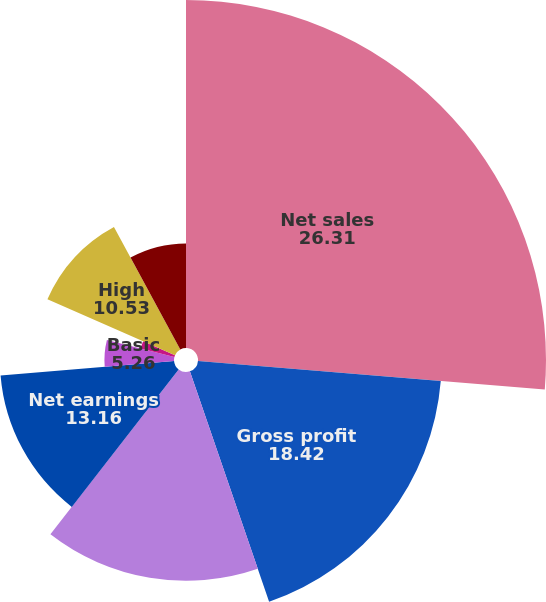<chart> <loc_0><loc_0><loc_500><loc_500><pie_chart><fcel>Net sales<fcel>Gross profit<fcel>Earnings before income taxes<fcel>Net earnings<fcel>Basic<fcel>Diluted<fcel>High<fcel>Low<fcel>Dividends declared per share<nl><fcel>26.31%<fcel>18.42%<fcel>15.79%<fcel>13.16%<fcel>5.26%<fcel>2.63%<fcel>10.53%<fcel>7.9%<fcel>0.0%<nl></chart> 